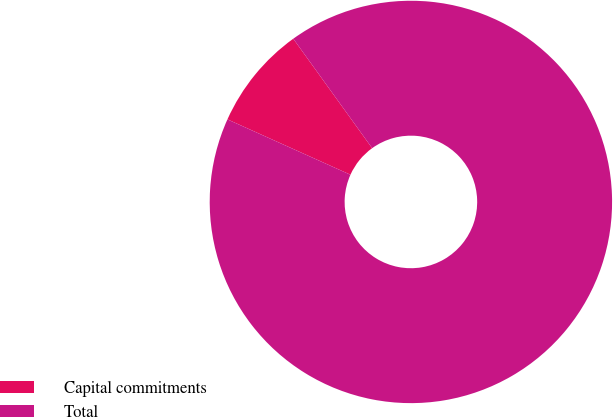Convert chart to OTSL. <chart><loc_0><loc_0><loc_500><loc_500><pie_chart><fcel>Capital commitments<fcel>Total<nl><fcel>8.33%<fcel>91.67%<nl></chart> 